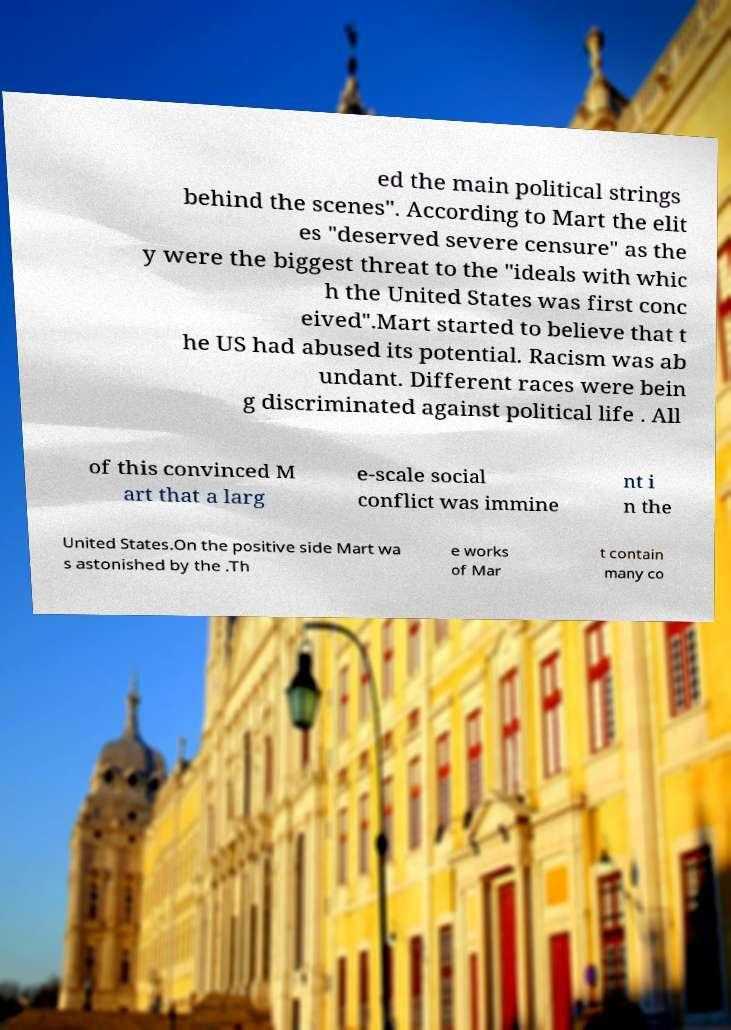Can you read and provide the text displayed in the image?This photo seems to have some interesting text. Can you extract and type it out for me? ed the main political strings behind the scenes". According to Mart the elit es "deserved severe censure" as the y were the biggest threat to the "ideals with whic h the United States was first conc eived".Mart started to believe that t he US had abused its potential. Racism was ab undant. Different races were bein g discriminated against political life . All of this convinced M art that a larg e-scale social conflict was immine nt i n the United States.On the positive side Mart wa s astonished by the .Th e works of Mar t contain many co 